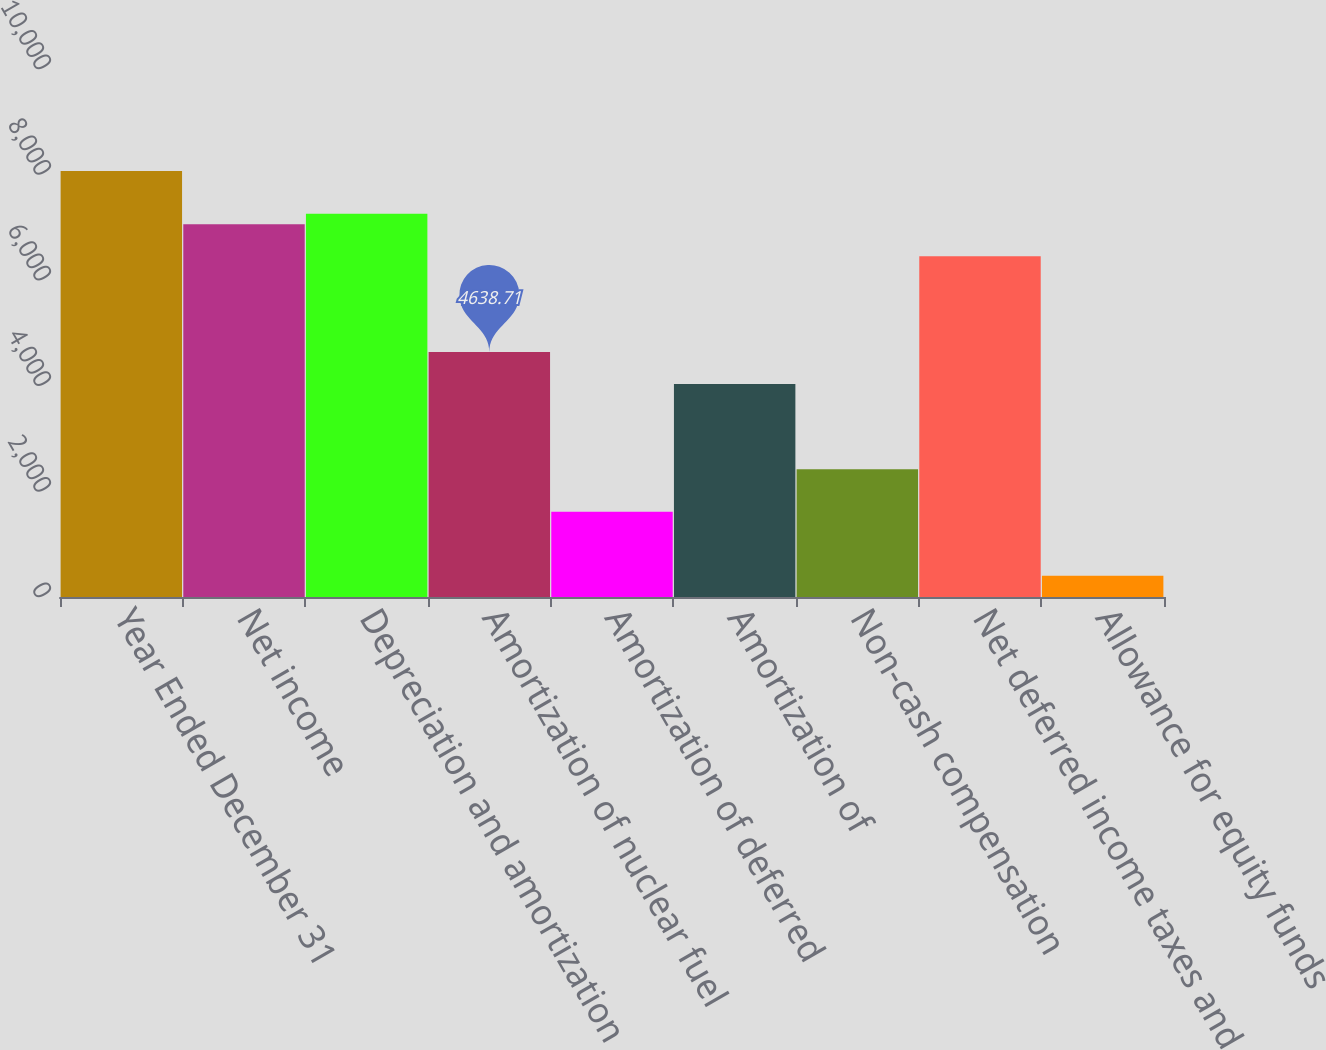<chart> <loc_0><loc_0><loc_500><loc_500><bar_chart><fcel>Year Ended December 31<fcel>Net income<fcel>Depreciation and amortization<fcel>Amortization of nuclear fuel<fcel>Amortization of deferred<fcel>Amortization of<fcel>Non-cash compensation<fcel>Net deferred income taxes and<fcel>Allowance for equity funds<nl><fcel>8067.1<fcel>7058.75<fcel>7260.42<fcel>4638.71<fcel>1613.66<fcel>4033.7<fcel>2420.34<fcel>6453.74<fcel>403.64<nl></chart> 